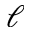<formula> <loc_0><loc_0><loc_500><loc_500>\ell</formula> 